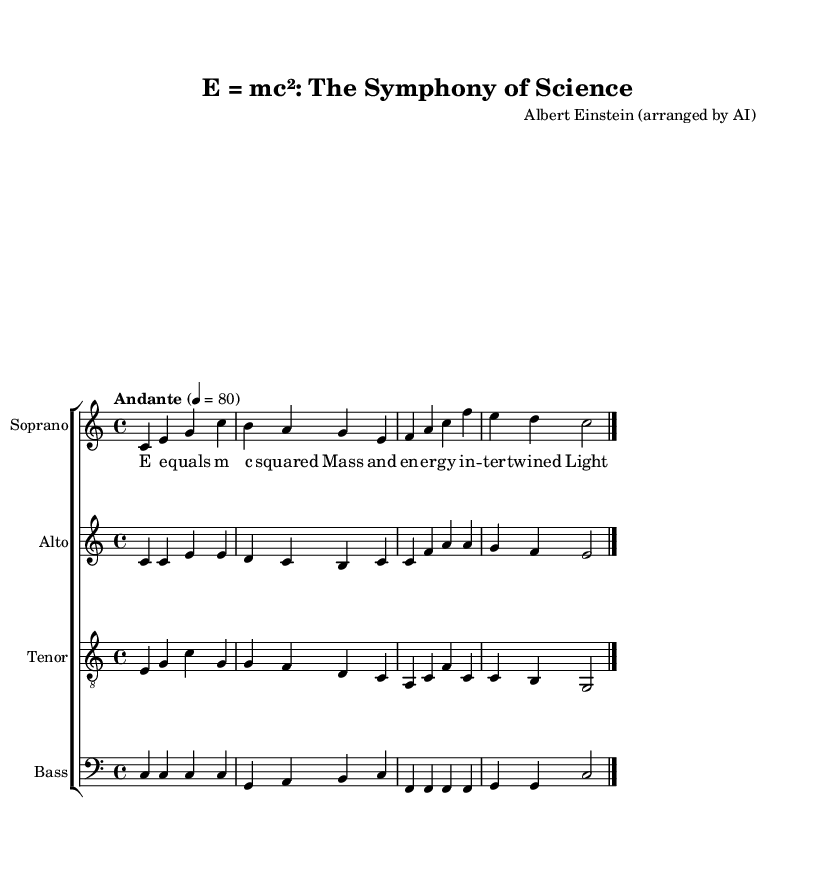What is the key signature of this music? The key signature is indicated at the beginning of the score, and it shows no sharps or flats. This corresponds to the C major key.
Answer: C major What is the time signature of this music? The time signature is shown in the left hand part of the score. It is marked as 4/4, meaning there are four beats in a measure and the quarter note receives one beat.
Answer: 4/4 What is the tempo marking of this music? The tempo marking appears in the global definition at the start of the score, indicated as "Andante" with a metronome marking of 80 beats per minute.
Answer: Andante, 80 How many vocal parts are included in this arrangement? By examining the choir staff, you can identify four distinct staffs: Soprano, Alto, Tenor, and Bass, which collectively represent the vocal parts.
Answer: Four Which famous equation is represented in this choral arrangement? The lyrics of the soprano line contain the phrase "E equals mc squared," which directly mentions Einstein's famous equation about mass and energy equivalence.
Answer: E equals mc squared What is the lyrical theme of this choral arrangement? The lyrics discuss concepts related to mass, energy, and nature's truth, which fundamentally tie back to scientific principles and theories, particularly relating to physics.
Answer: Scientific principles What type of music is this arrangement based on? This choral arrangement is based on a famous scientific quote that has been adapted into a musical format suitable for choral performance, blending science with art.
Answer: Choral arrangement of a scientific quote 